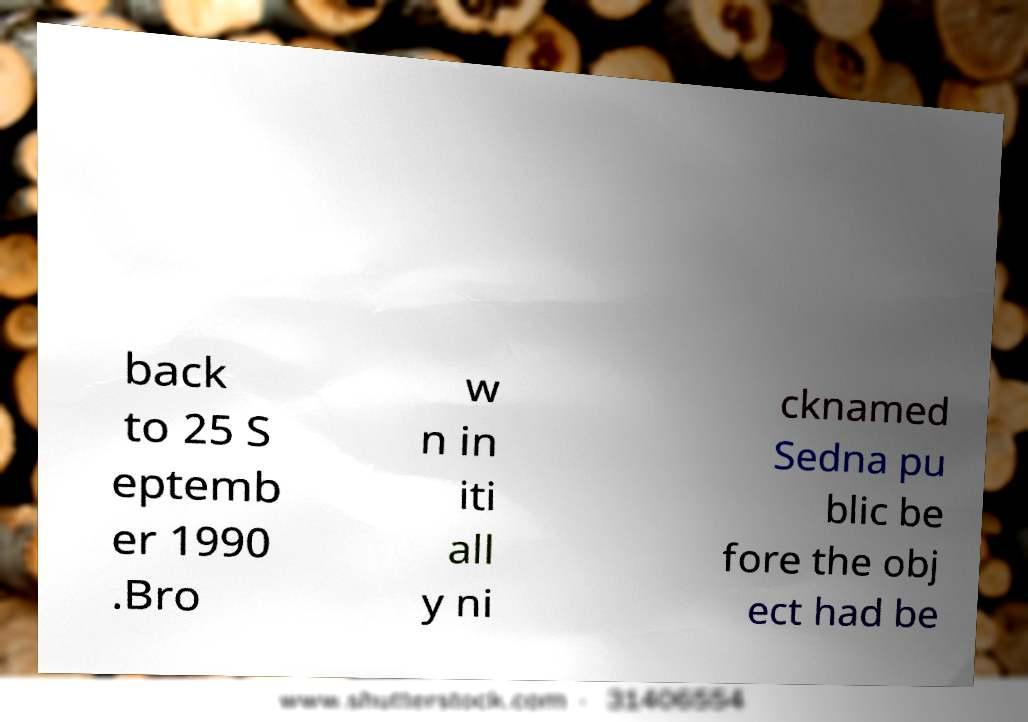There's text embedded in this image that I need extracted. Can you transcribe it verbatim? back to 25 S eptemb er 1990 .Bro w n in iti all y ni cknamed Sedna pu blic be fore the obj ect had be 